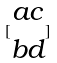<formula> <loc_0><loc_0><loc_500><loc_500>[ \begin{matrix} a c \\ b d \end{matrix} ]</formula> 